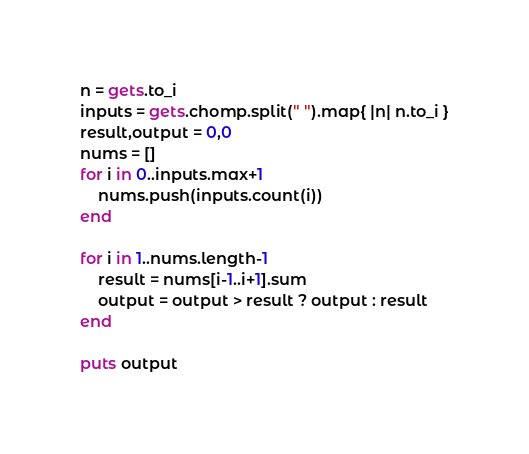<code> <loc_0><loc_0><loc_500><loc_500><_Ruby_>n = gets.to_i
inputs = gets.chomp.split(" ").map{ |n| n.to_i }
result,output = 0,0
nums = []
for i in 0..inputs.max+1
	nums.push(inputs.count(i))
end

for i in 1..nums.length-1
	result = nums[i-1..i+1].sum
	output = output > result ? output : result
end

puts output</code> 